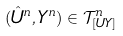Convert formula to latex. <formula><loc_0><loc_0><loc_500><loc_500>( \hat { U } ^ { n } , Y ^ { n } ) \in \mathcal { T } _ { [ U Y ] } ^ { n }</formula> 